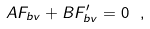<formula> <loc_0><loc_0><loc_500><loc_500>A F _ { b v } + B F ^ { \prime } _ { b v } = 0 \ ,</formula> 